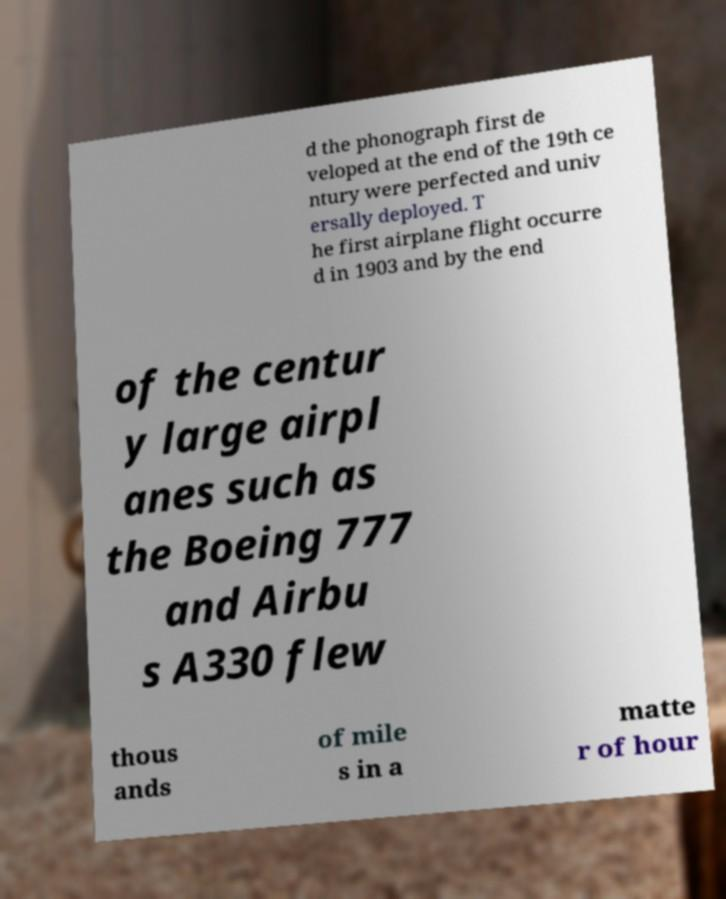What messages or text are displayed in this image? I need them in a readable, typed format. d the phonograph first de veloped at the end of the 19th ce ntury were perfected and univ ersally deployed. T he first airplane flight occurre d in 1903 and by the end of the centur y large airpl anes such as the Boeing 777 and Airbu s A330 flew thous ands of mile s in a matte r of hour 